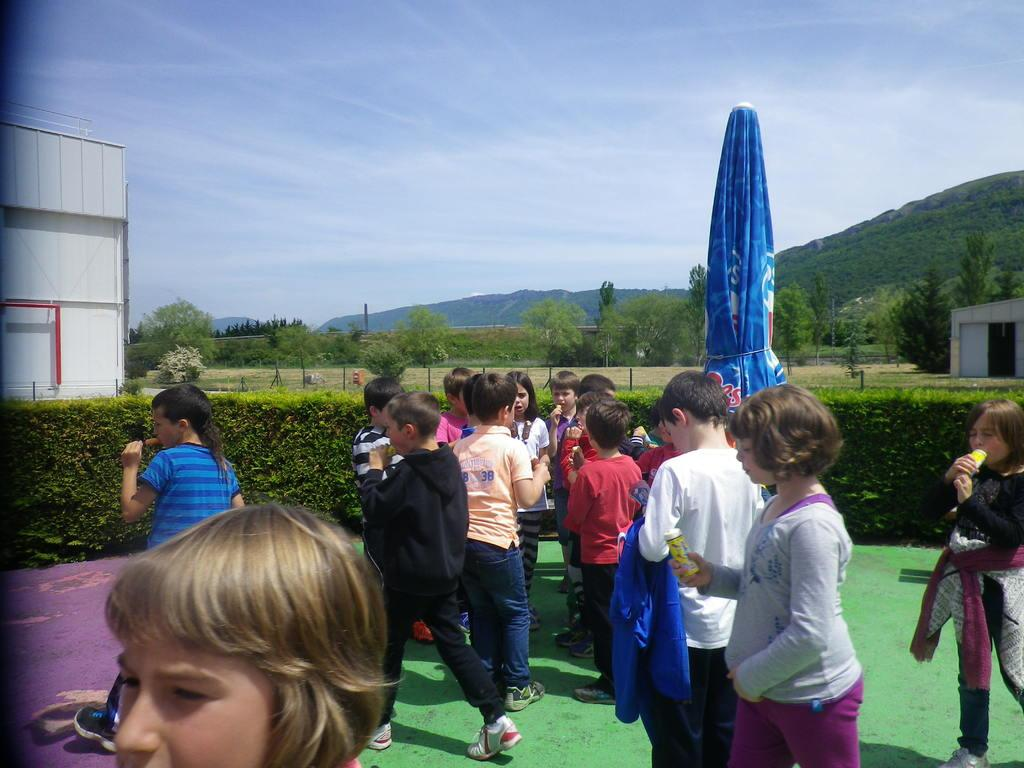What is the main subject of the image? The main subject of the image is a group of children. Where are the children located in the image? The children are standing on the ground. What type of environment surrounds the children? There is greenery around the children. What can be seen in the background of the image? There are trees and a mountain in the background of the image. How many bananas are being used as cannonballs in the image? There are no bananas or cannons present in the image. What type of comfort can be seen being provided to the children in the image? There is no specific comfort being provided to the children in the image; they are simply standing on the ground. 